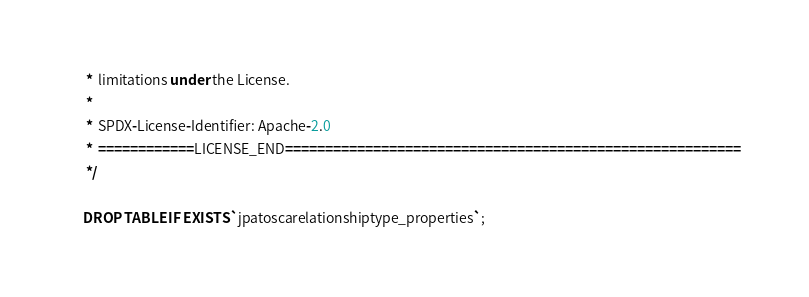Convert code to text. <code><loc_0><loc_0><loc_500><loc_500><_SQL_> *  limitations under the License.
 *
 *  SPDX-License-Identifier: Apache-2.0
 *  ============LICENSE_END=========================================================
 */

DROP TABLE IF EXISTS `jpatoscarelationshiptype_properties`;
</code> 